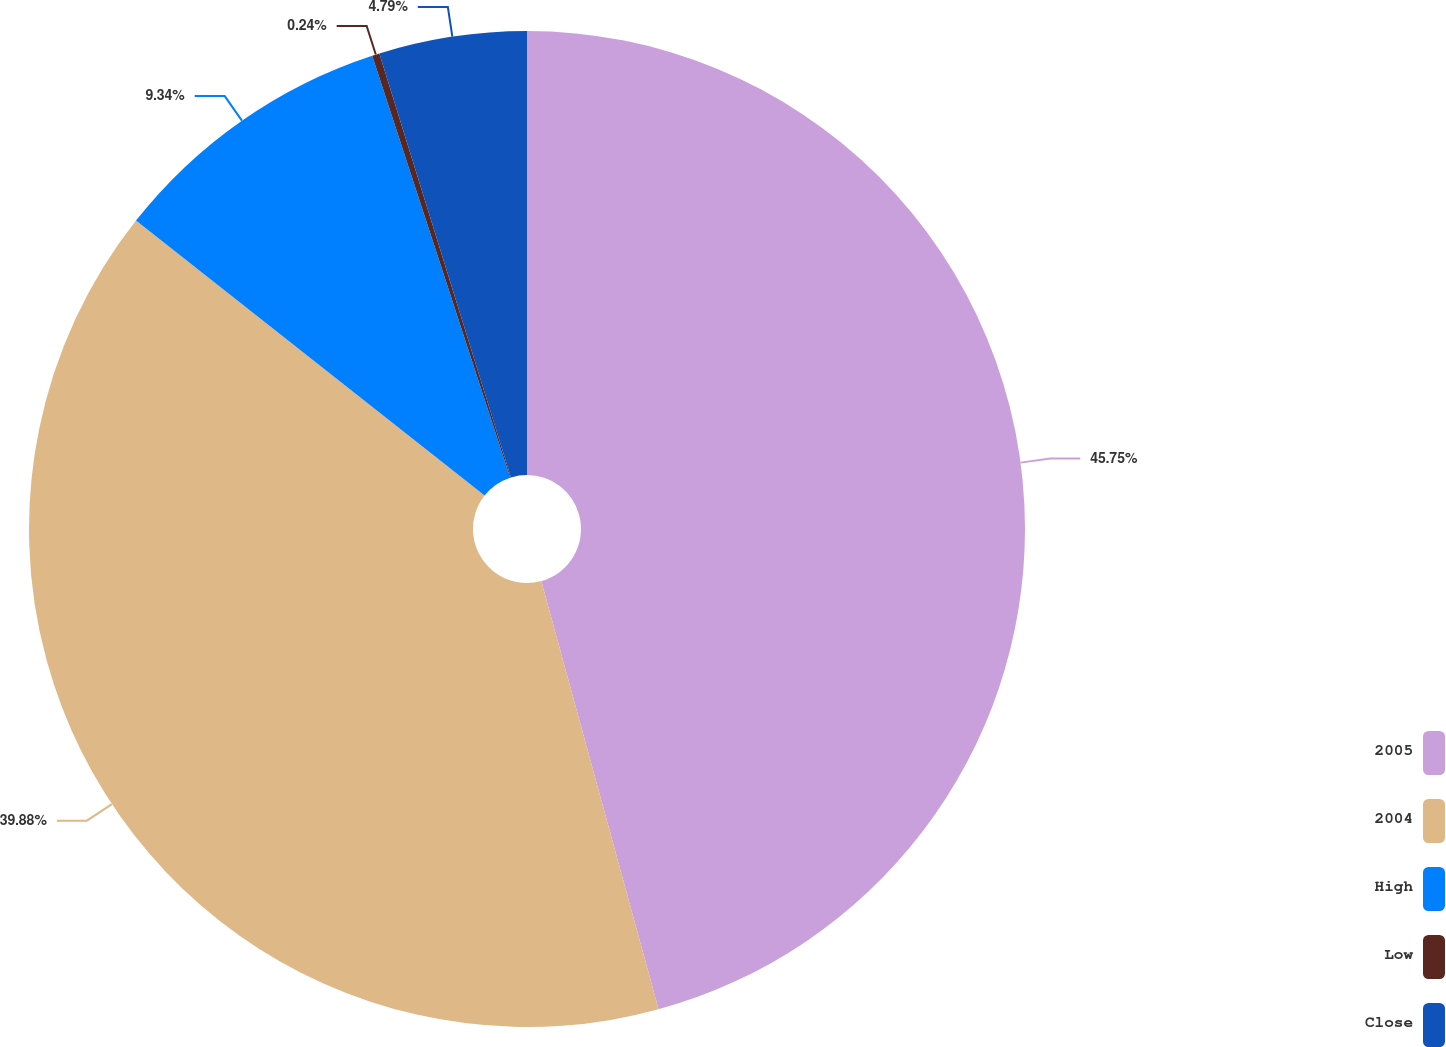<chart> <loc_0><loc_0><loc_500><loc_500><pie_chart><fcel>2005<fcel>2004<fcel>High<fcel>Low<fcel>Close<nl><fcel>45.74%<fcel>39.88%<fcel>9.34%<fcel>0.24%<fcel>4.79%<nl></chart> 